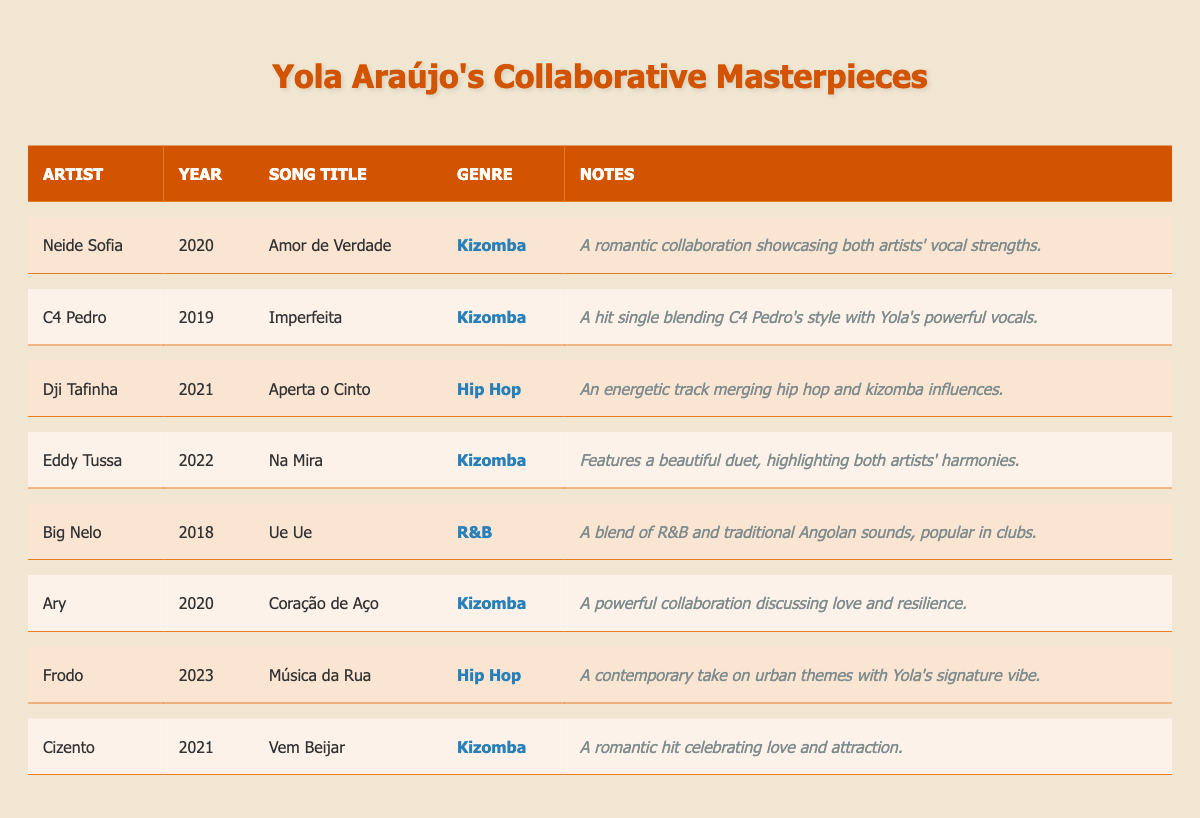What is the title of the song Yola Araújo collaborated on with Neide Sofia? The collaboration with Neide Sofia is titled "Amor de Verdade." This can be found directly in the table under the "Song Title" column corresponding to Neide Sofia's entry.
Answer: Amor de Verdade How many collaborations does Yola Araújo have in the Kizomba genre? By reviewing the table, I count the number of entries where the genre is listed as Kizomba. There are 5 collaborations under that genre.
Answer: 5 In which year did Yola collaborate with C4 Pedro? The year of the collaboration with C4 Pedro is noted as 2019 in the corresponding row of the table.
Answer: 2019 Is "Coração de Aço" a collaboration in the Hip Hop genre? Checking the genre listed next to "Coração de Aço" in the table shows that it is categorized under Kizomba, not Hip Hop.
Answer: No Which artists collaborated with Yola Araújo in 2021? The table lists two collaborations from 2021: the first is "Aperta o Cinto" with Dji Tafinha and the second is "Vem Beijar" with Cizento. Both are noted under the Year column for 2021.
Answer: Dji Tafinha and Cizento What is the total number of hip hop collaborations Yola Araújo has? The table shows two entries categorized under Hip Hop: "Aperta o Cinto" with Dji Tafinha and "Música da Rua" with Frodo. Thus, I sum these two entries to find the total number of hip hop collaborations.
Answer: 2 Which collaboration features the song "Na Mira"? The song "Na Mira" is a collaboration with Eddy Tussa as listed in the table, where it is specified in the “Song Title” column under Eddy Tussa's entry.
Answer: Eddy Tussa What genre does the song "Ue Ue" fall under? The table indicates that "Ue Ue," performed in collaboration with Big Nelo, falls under the R&B genre, as noted in the corresponding row.
Answer: R&B How many of Yola Araújo's collaborations were released in the years 2020 and 2021 combined? I examine the table entries for the years 2020 (3 collaborations) and 2021 (2 collaborations). By adding these, I find that there are a total of 5 collaborations released in those years.
Answer: 5 Did Yola collaborate with any artists in 2020? If yes, name them. Looking at the table, there are three collaborations in 2020: "Amor de Verdade" with Neide Sofia, "Coração de Aço" with Ary, and "Imperfeita" with C4 Pedro. Therefore, yes, Yola did collaborate in that year.
Answer: Yes, Neide Sofia, C4 Pedro, Ary 